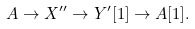Convert formula to latex. <formula><loc_0><loc_0><loc_500><loc_500>A \to X ^ { \prime \prime } \to Y ^ { \prime } [ 1 ] \to A [ 1 ] .</formula> 